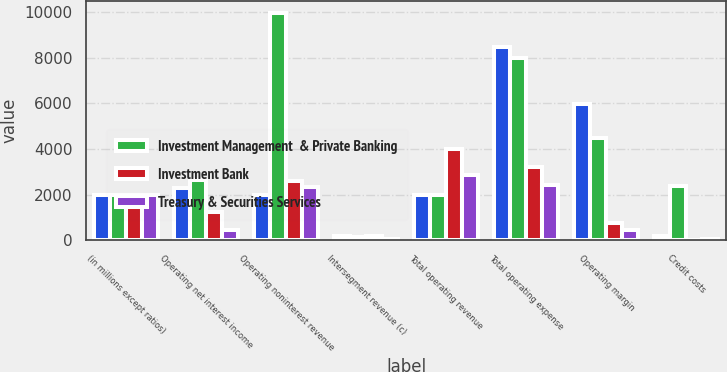Convert chart to OTSL. <chart><loc_0><loc_0><loc_500><loc_500><stacked_bar_chart><ecel><fcel>(in millions except ratios)<fcel>Operating net interest income<fcel>Operating noninterest revenue<fcel>Intersegment revenue (c)<fcel>Total operating revenue<fcel>Total operating expense<fcel>Operating margin<fcel>Credit costs<nl><fcel>nan<fcel>2003<fcel>2277<fcel>2003<fcel>191<fcel>2003<fcel>8470<fcel>5970<fcel>181<nl><fcel>Investment Management  & Private Banking<fcel>2002<fcel>2642<fcel>9988<fcel>130<fcel>2003<fcel>8012<fcel>4486<fcel>2393<nl><fcel>Investment Bank<fcel>2003<fcel>1219<fcel>2586<fcel>187<fcel>3992<fcel>3217<fcel>775<fcel>1<nl><fcel>Treasury & Securities Services<fcel>2003<fcel>467<fcel>2348<fcel>62<fcel>2878<fcel>2428<fcel>450<fcel>35<nl></chart> 